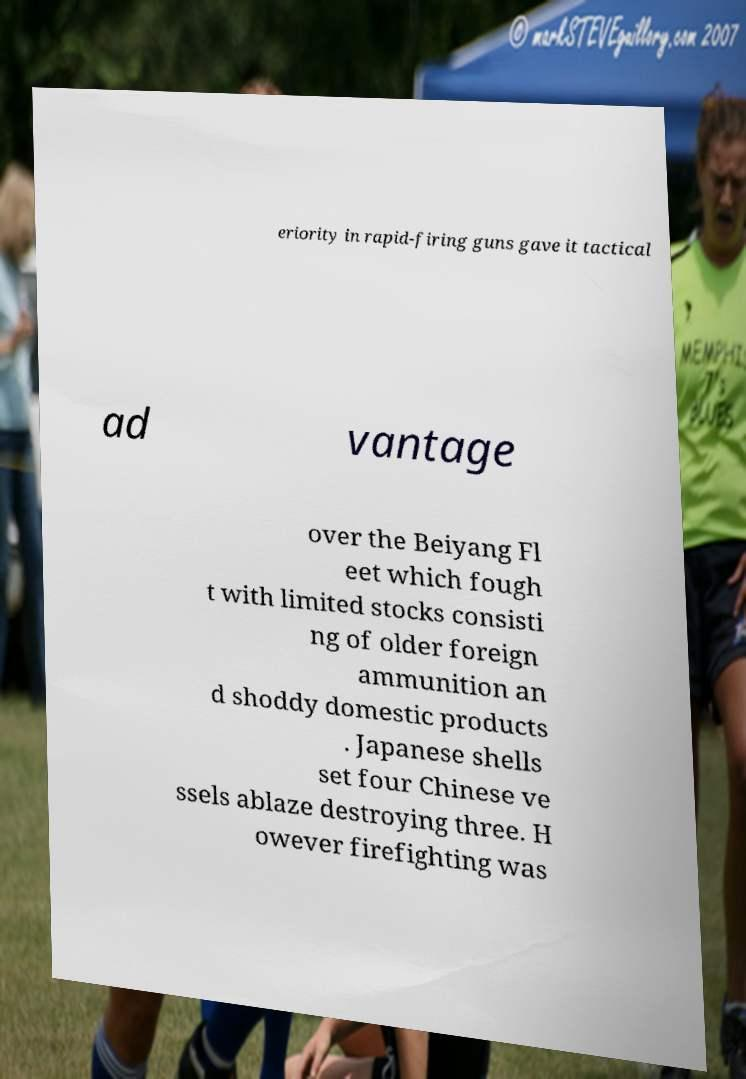Can you read and provide the text displayed in the image?This photo seems to have some interesting text. Can you extract and type it out for me? eriority in rapid-firing guns gave it tactical ad vantage over the Beiyang Fl eet which fough t with limited stocks consisti ng of older foreign ammunition an d shoddy domestic products . Japanese shells set four Chinese ve ssels ablaze destroying three. H owever firefighting was 